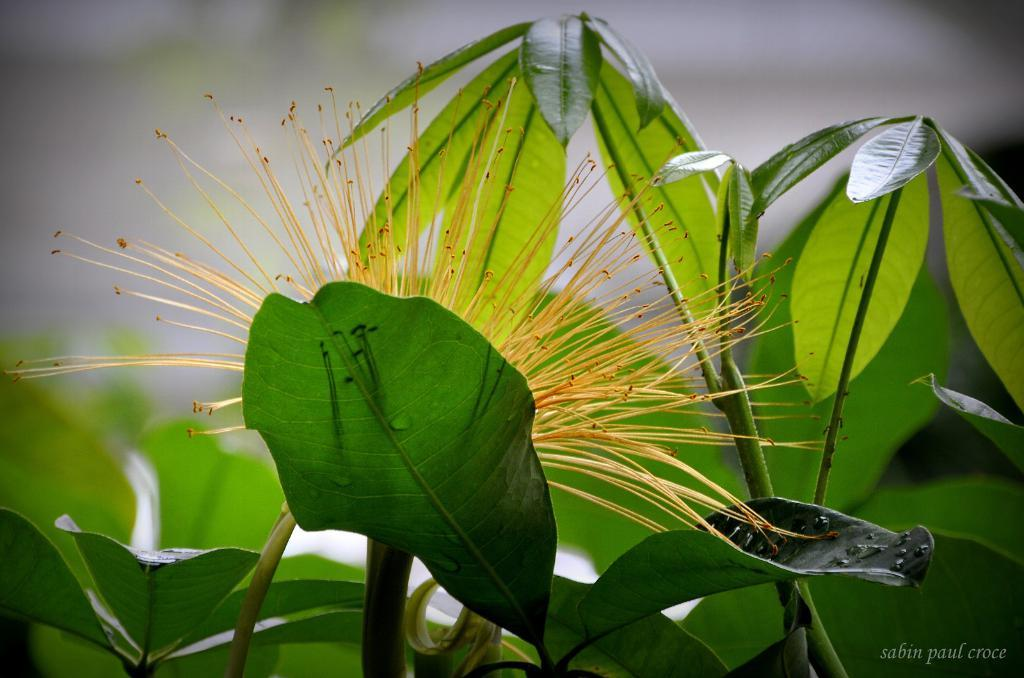What type of plant material is present in the image? There are green leaves in the image. Can you describe the flower in the image? The flower in the image has yellow and orange colors. What is the appearance of the background in the image? The background of the image is blurred. What type of tooth can be seen in the image? There is no tooth present in the image; it features green leaves and a flower. Is there a mailbox visible in the image? No, there is no mailbox present in the image. 